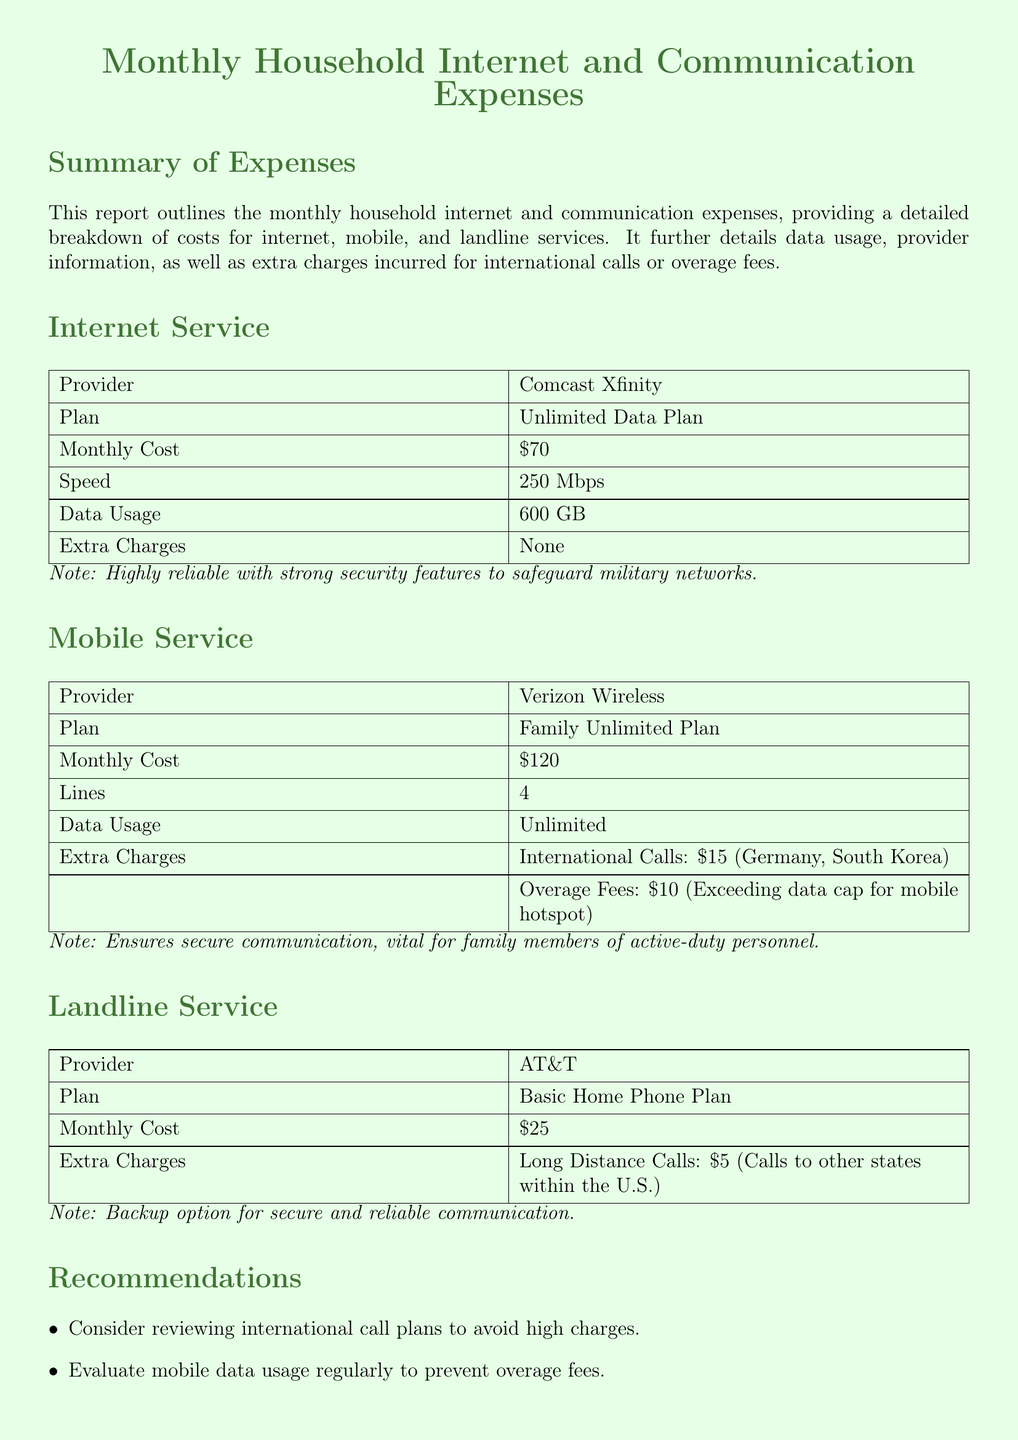What is the monthly cost for internet service? The monthly cost for internet service is provided in the document under the Internet Service section.
Answer: $70 How many lines are included in the mobile service plan? The document specifies the number of lines included in the mobile service plan under the Mobile Service section.
Answer: 4 What is the maximum speed of the internet plan? The maximum speed of the internet plan is detailed in the Internet Service section of the document.
Answer: 250 Mbps What additional charge is incurred for international calls under the mobile service? The document outlines any extra charges related to international calls in the Mobile Service section.
Answer: $15 What is the extra charge for long-distance calls on the landline service? The extra charge for long-distance calls is mentioned under the Landline Service section of the document.
Answer: $5 Which provider offers the Basic Home Phone Plan? The provider information for the Basic Home Phone Plan is indicated in the Landline Service section of the document.
Answer: AT&T What type of plan is provided by Verizon Wireless? The document describes the type of plan offered by Verizon Wireless in the Mobile Service section.
Answer: Family Unlimited Plan Why is the internet service considered reliable for military networks? The document includes a note explaining the reliability of the internet service in safeguarding military networks.
Answer: Strong security features What recommendation is given concerning mobile data usage? The recommendations related to mobile data usage are mentioned in the Recommendations section of the document.
Answer: Evaluate data usage regularly 